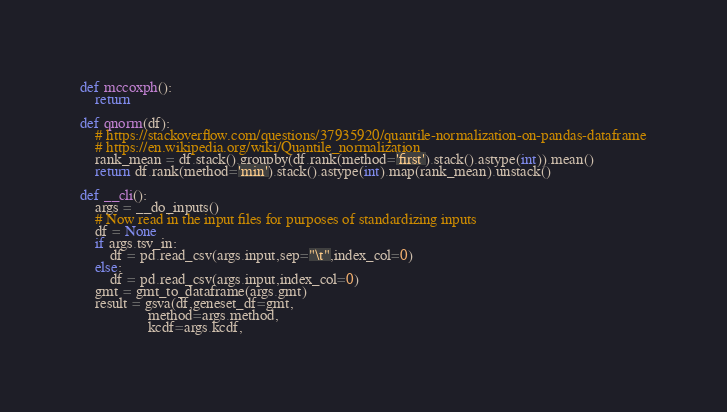<code> <loc_0><loc_0><loc_500><loc_500><_Python_>def mccoxph():
    return

def qnorm(df):
    # https://stackoverflow.com/questions/37935920/quantile-normalization-on-pandas-dataframe
    # https://en.wikipedia.org/wiki/Quantile_normalization
    rank_mean = df.stack().groupby(df.rank(method='first').stack().astype(int)).mean()
    return df.rank(method='min').stack().astype(int).map(rank_mean).unstack()

def __cli():
    args = __do_inputs()
    # Now read in the input files for purposes of standardizing inputs
    df = None
    if args.tsv_in:
        df = pd.read_csv(args.input,sep="\t",index_col=0)
    else:
        df = pd.read_csv(args.input,index_col=0)
    gmt = gmt_to_dataframe(args.gmt)
    result = gsva(df,geneset_df=gmt,
                  method=args.method,
                  kcdf=args.kcdf,</code> 